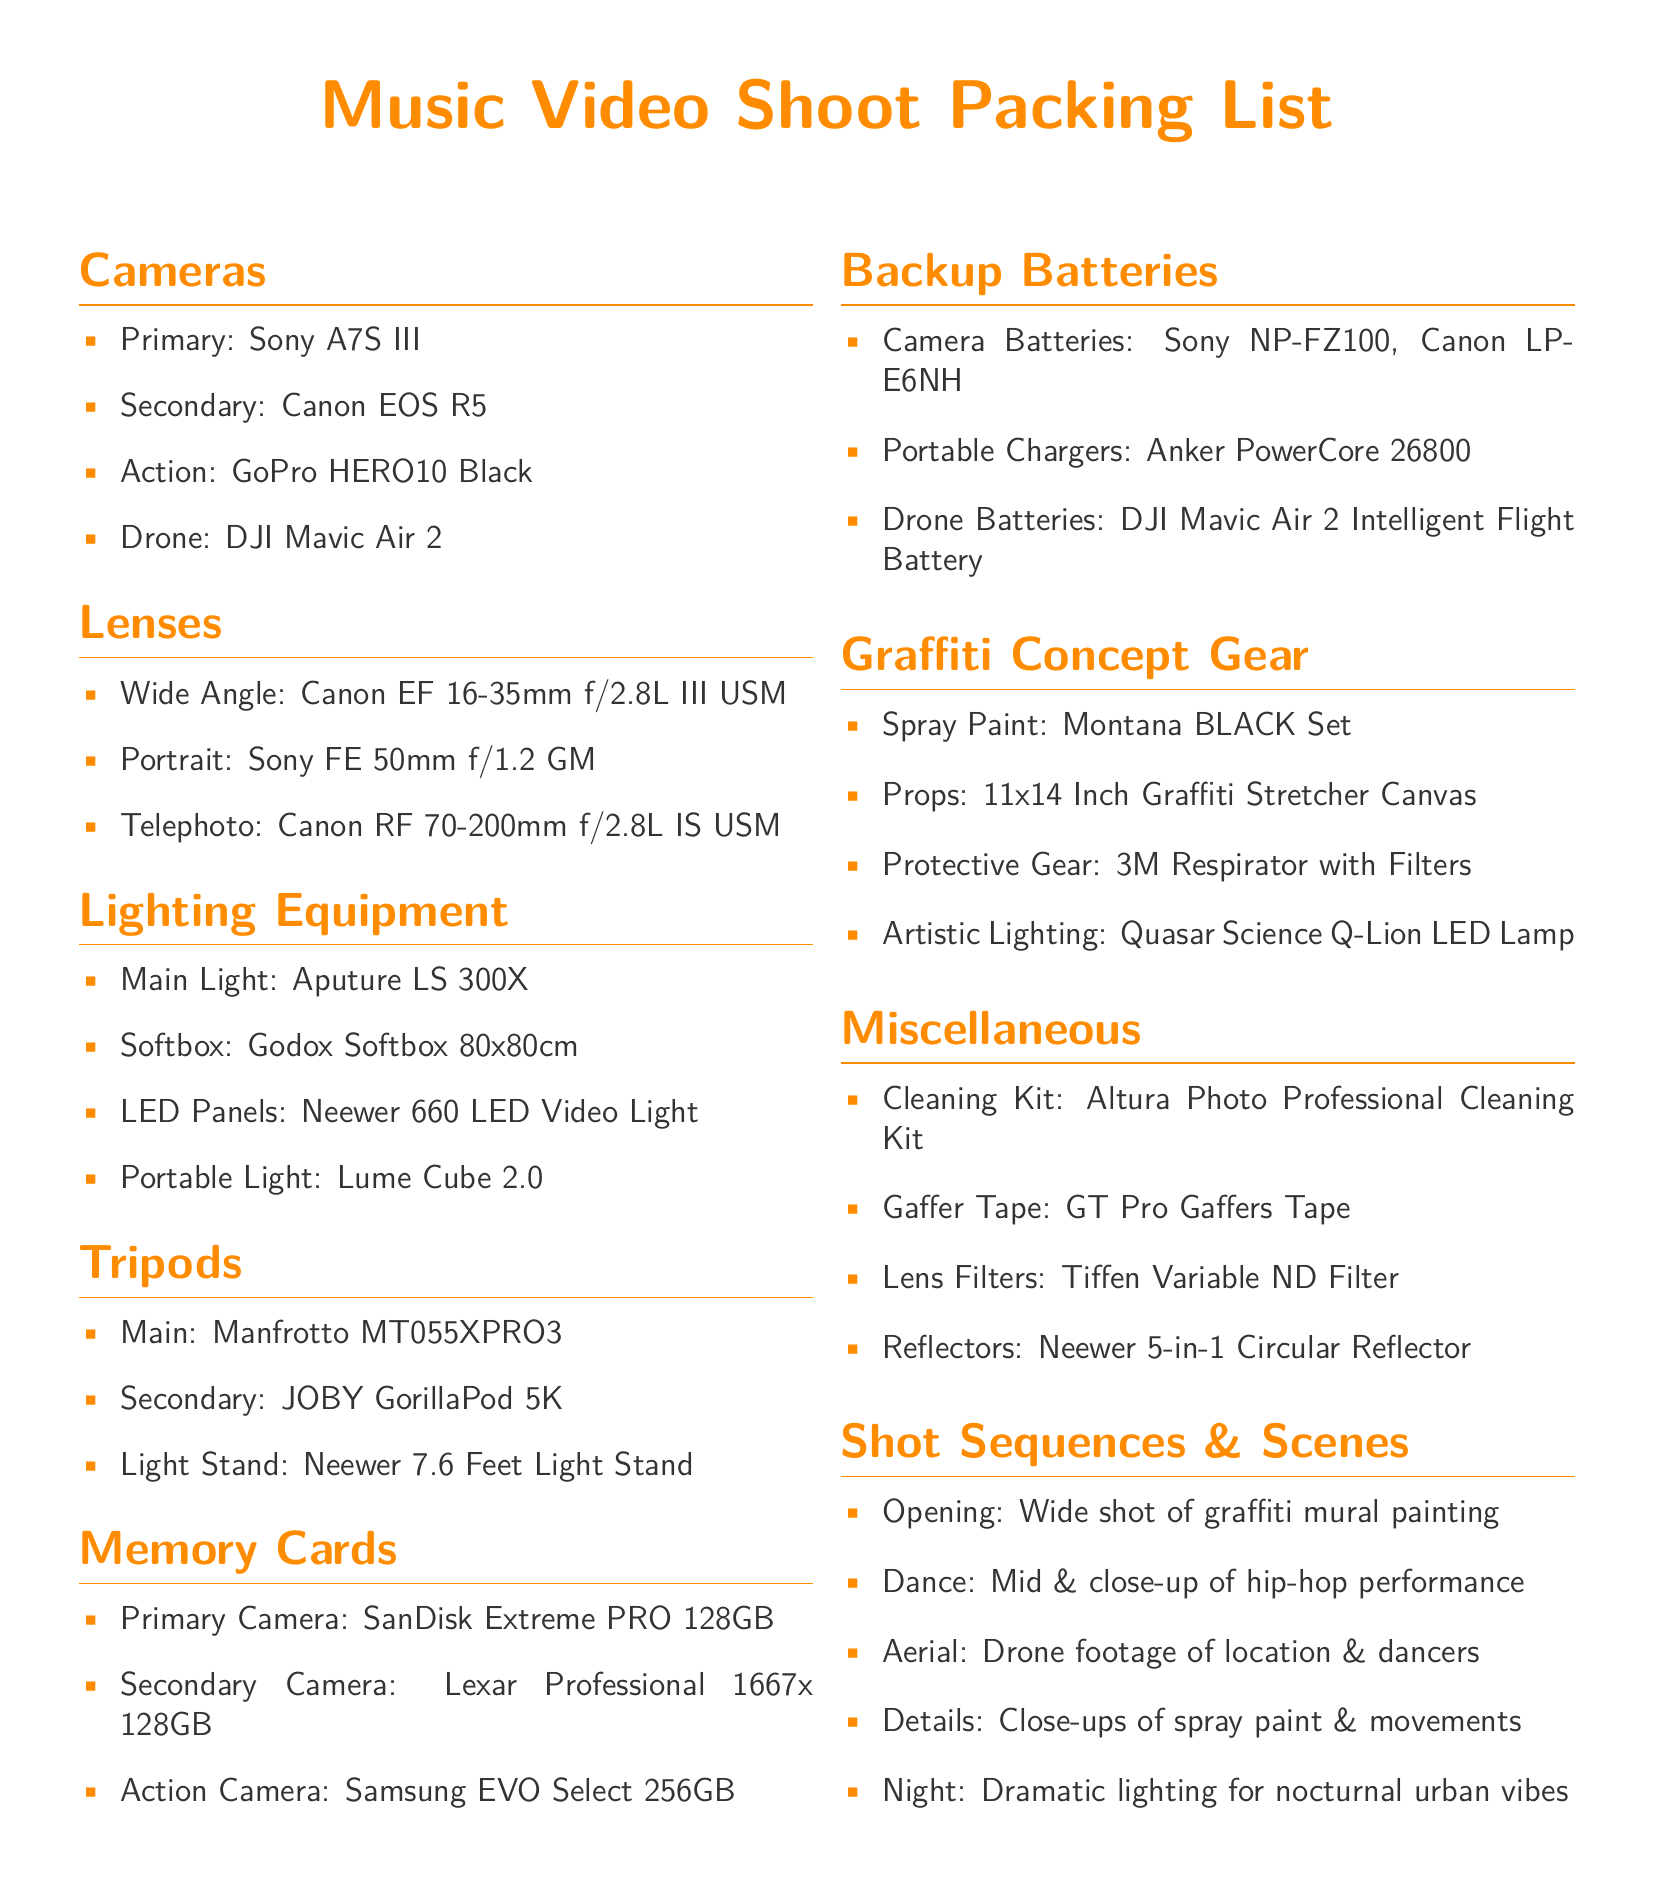what is the primary camera listed? The primary camera is specified in the Cameras section, which is the Sony A7S III.
Answer: Sony A7S III how many types of light stands are mentioned? The document lists three types of tripods, including one category specifically for light stands.
Answer: 1 what is the size of the primary memory card? The primary memory card is detailed in the Memory Cards section, which indicates it has a capacity of 128GB.
Answer: 128GB which drone is included in the packing list? The drone mentioned in the Cameras section is identified specifically as the DJI Mavic Air 2.
Answer: DJI Mavic Air 2 what is one of the props listed for the graffiti concept? The props for the graffiti concept are found in the Graffiti Concept Gear section, specifically mentioning a canvas.
Answer: 11x14 Inch Graffiti Stretcher Canvas which lighting equipment is described as the main light? The main light is noted in the Lighting Equipment section, specifically the Aputure LS 300X.
Answer: Aputure LS 300X how many types of lenses are included? The document states a total of three types of lenses listed in the Lenses section.
Answer: 3 what type of footage is planned for the aerial shot? The shot sequences mention that aerial footage will feature location and dancers, indicating the type of content.
Answer: Drone footage of location & dancers what kind of protective gear is listed? The protective gear is specifically named in the Graffiti Concept Gear section as a respirator.
Answer: 3M Respirator with Filters 